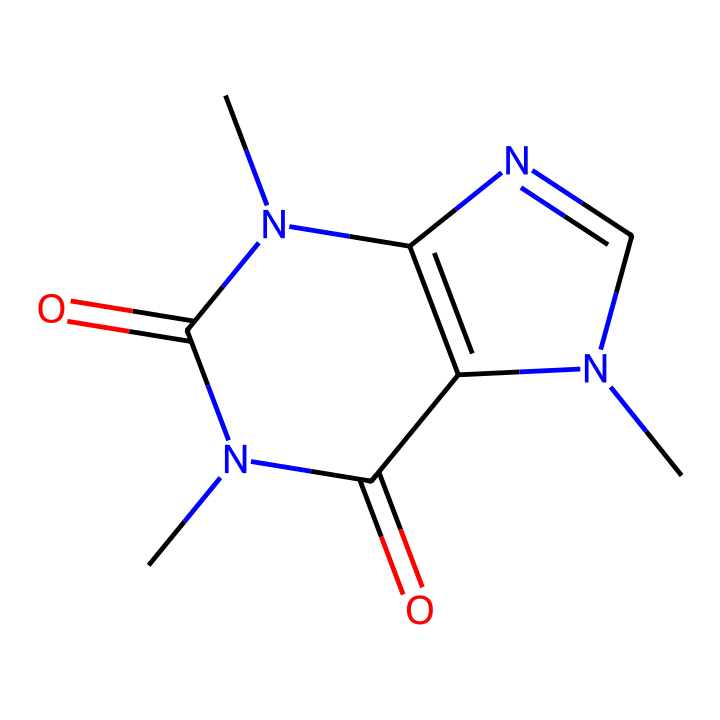What is the molecular formula of caffeine? The SMILES representation breaks down into distinct elements: there are 8 carbon (C), 10 hydrogen (H), 4 nitrogen (N), and 2 oxygen (O) atoms, leading to the formula C8H10N4O2.
Answer: C8H10N4O2 How many nitrogen atoms are in the caffeine structure? By analyzing the SMILES, we can identify four nitrogen (N) symbols in the structure, confirming that caffeine contains four nitrogen atoms.
Answer: 4 Is caffeine classified as an alkaloid? The presence of multiple nitrogen atoms in a natural plant product typically indicates it is an alkaloid; thus, caffeine, with its nitrogen-rich structure, is identified as such.
Answer: yes What type of bond connects carbon and nitrogen in caffeine? The molecule shows several covalent connections throughout the structure; specifically, the bonds between carbon and nitrogen atoms are covalent bonds, which are characterized by the sharing of electron pairs.
Answer: covalent What is the primary functional group present in caffeine? Examination of the SMILES structure reveals functional groups typical in caffeine, such as amine and ketone; in particular, the presence of carbonyl groups indicates that ketones are the primary functional group.
Answer: ketone Which element appears most frequently in the caffeine structure? By counting the occurrences of each atom in the structure from the SMILES, we find that carbon (C) appears eight times, more than any other element in the molecule.
Answer: carbon What is the total number of rings in the caffeine molecular structure? Analyzing the SMILES representation reveals two interconnected rings formed by the arrangement of carbon and nitrogen atoms, indicating that caffeine has two rings in its structure.
Answer: 2 